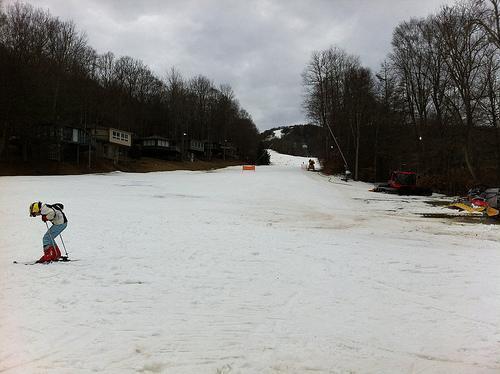How many people are in this picture?
Give a very brief answer. 1. 